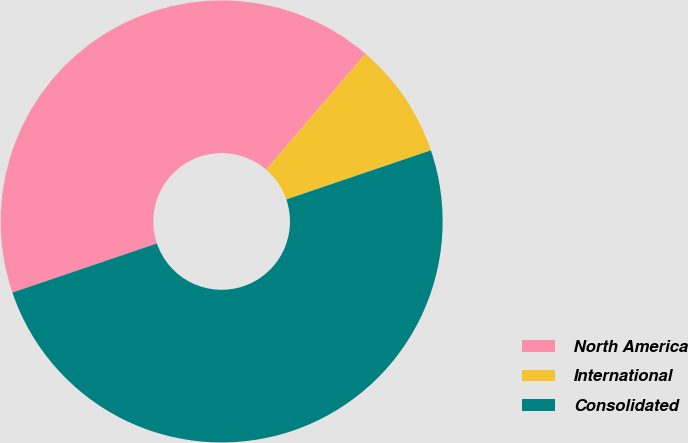Convert chart. <chart><loc_0><loc_0><loc_500><loc_500><pie_chart><fcel>North America<fcel>International<fcel>Consolidated<nl><fcel>41.5%<fcel>8.5%<fcel>50.0%<nl></chart> 